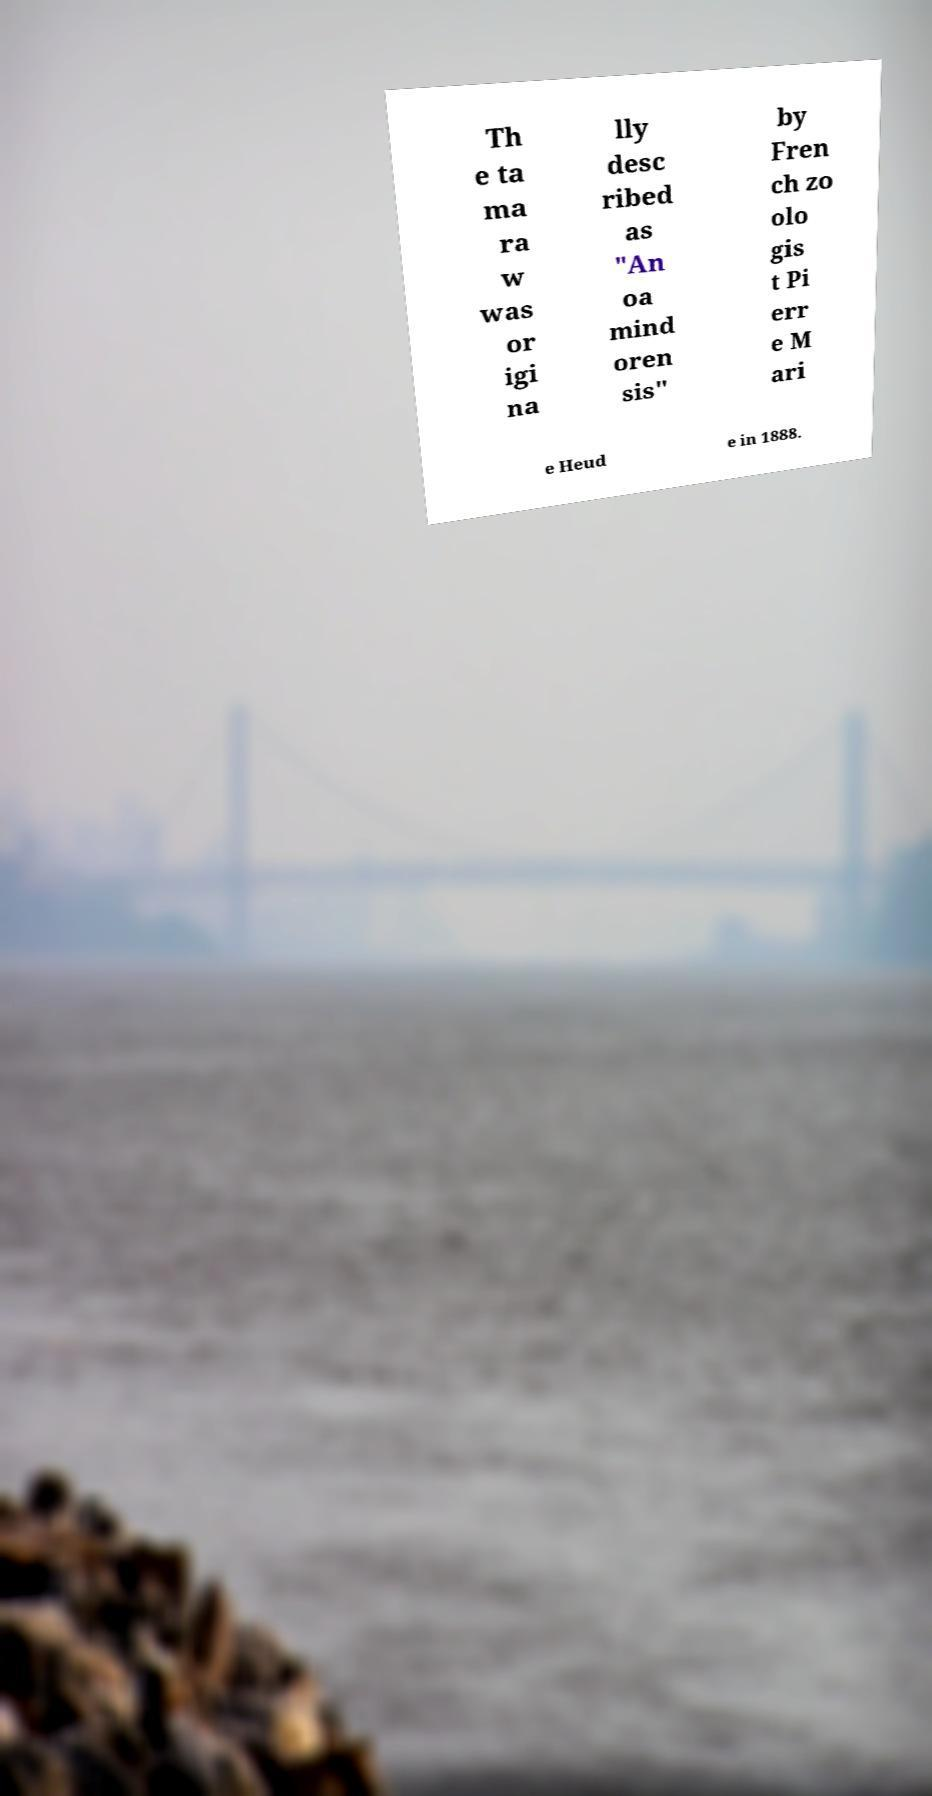For documentation purposes, I need the text within this image transcribed. Could you provide that? Th e ta ma ra w was or igi na lly desc ribed as "An oa mind oren sis" by Fren ch zo olo gis t Pi err e M ari e Heud e in 1888. 